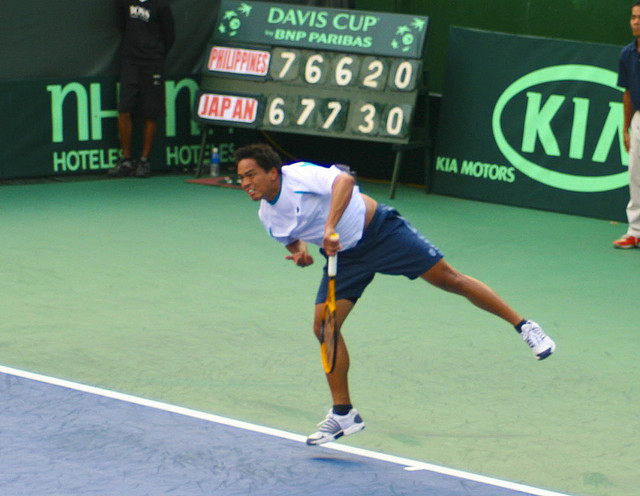<image>What shot is this player hitting? It is unknown what shot this player is hitting. It may be a scoring shot, a serve, or a backhand. What shot is this player hitting? I am not sure what shot this player is hitting. It could be a scoring shot, serve, backhand, chip shot, or return. 